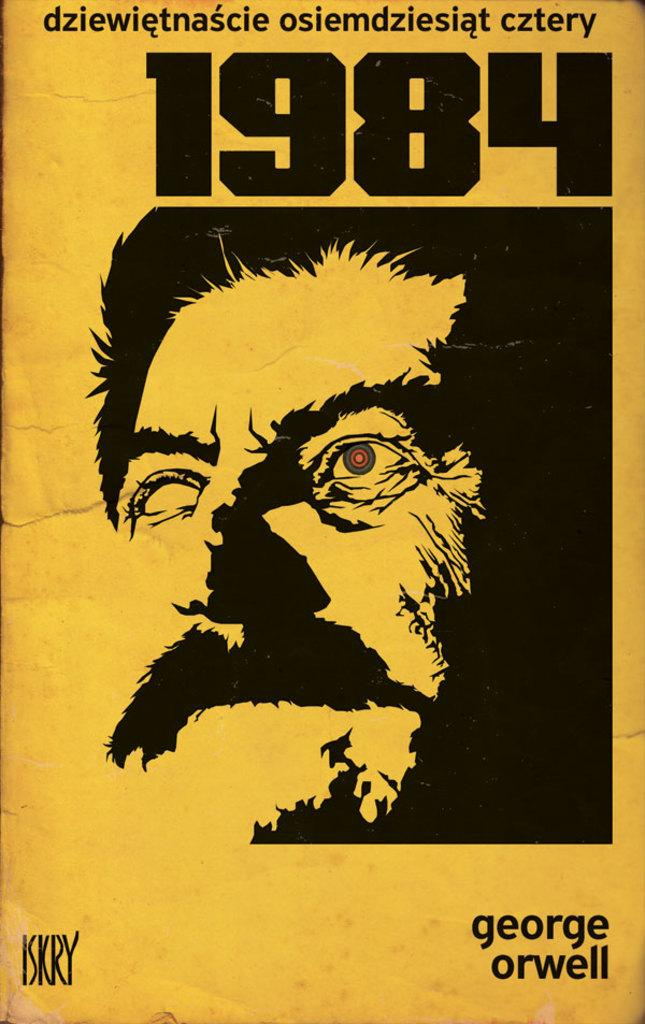<image>
Give a short and clear explanation of the subsequent image. A foreign language cover of George Orwell's book 1984. 